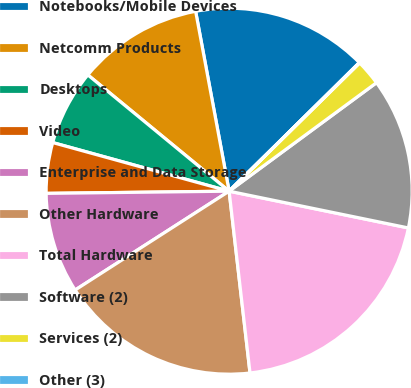Convert chart to OTSL. <chart><loc_0><loc_0><loc_500><loc_500><pie_chart><fcel>Notebooks/Mobile Devices<fcel>Netcomm Products<fcel>Desktops<fcel>Video<fcel>Enterprise and Data Storage<fcel>Other Hardware<fcel>Total Hardware<fcel>Software (2)<fcel>Services (2)<fcel>Other (3)<nl><fcel>15.53%<fcel>11.11%<fcel>6.68%<fcel>4.47%<fcel>8.89%<fcel>17.74%<fcel>19.96%<fcel>13.32%<fcel>2.26%<fcel>0.04%<nl></chart> 